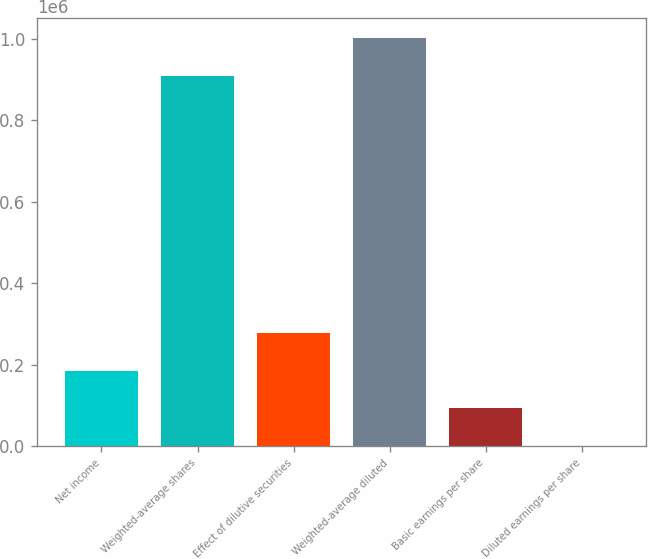<chart> <loc_0><loc_0><loc_500><loc_500><bar_chart><fcel>Net income<fcel>Weighted-average shares<fcel>Effect of dilutive securities<fcel>Weighted-average diluted<fcel>Basic earnings per share<fcel>Diluted earnings per share<nl><fcel>184955<fcel>909461<fcel>277424<fcel>1.00193e+06<fcel>92484.8<fcel>15.15<nl></chart> 